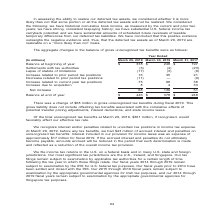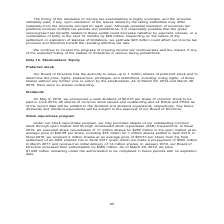According to Nortonlifelock's financial document, What is the change in gross unrecognized tax benefits during fiscal 2019? According to the financial document, $68 million. The relevant text states: "There was a change of $68 million in gross unrecognized tax benefits during fiscal 2019. This gross liability does not include offsett..." Also, What is the Balance at beginning of year for Year ended march 29, 2019?  According to the financial document, $378 (in millions). The relevant text states: "Balance at beginning of year $ 378 $ 248 $ 197 Settlements with tax authorities (3) (4) (23) Lapse of statute of limitations (17) (3)..." Also, What is the Balance at end of year for year ended  March 29, 2019? According to the financial document, $446 (in millions). The relevant text states: "Balance at end of year $ 446 $ 378 $ 248..." Also, can you calculate: What is the percentage constitution of unrecognized tax benefits, if recognized that would favorably affect effective tax rate for year ended March 29, 2019? Based on the calculation: 361/446, the result is 80.94 (percentage). This is based on the information: "Balance at end of year $ 446 $ 378 $ 248 tal unrecognized tax benefits at March 29, 2019, $361 million, if recognized, would favorably affect our effective tax rate...." The key data points involved are: 361, 446. Also, can you calculate: What is the total Balance at end of year for the fiscal years 2019, 2018, 2017? Based on the calculation: 446+378+248, the result is 1072 (in millions). This is based on the information: "Balance at beginning of year $ 378 $ 248 $ 197 Settlements with tax authorities (3) (4) (23) Lapse of statute of limitations (17) (3) Balance at beginning of year $ 378 $ 248 $ 197 Settlements with ta..." The key data points involved are: 248, 378, 446. Also, can you calculate: What is the average Balance at end of year for the fiscal years 2019, 2018, 2017? To answer this question, I need to perform calculations using the financial data. The calculation is: (446+378+248)/3, which equals 357.33 (in millions). This is based on the information: "Balance at beginning of year $ 378 $ 248 $ 197 Settlements with tax authorities (3) (4) (23) Lapse of statute of limitations (17) (3) Balance at beginning of year $ 378 $ 248 $ 197 Settlements with ta..." The key data points involved are: 248, 378, 446. 